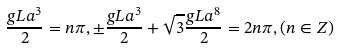Convert formula to latex. <formula><loc_0><loc_0><loc_500><loc_500>\frac { g L a ^ { 3 } } { 2 } = n \pi , \pm \frac { g L a ^ { 3 } } { 2 } + \sqrt { 3 } \frac { g L a ^ { 8 } } { 2 } = 2 n \pi , ( n \in Z )</formula> 